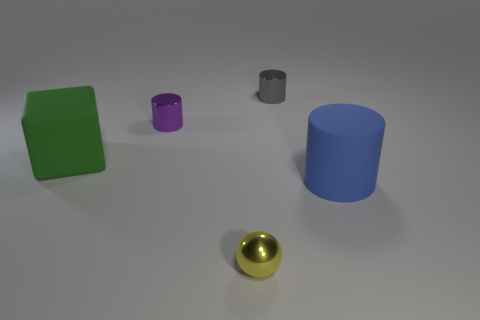Are there any yellow things made of the same material as the large green thing?
Your answer should be very brief. No. How many blue things are either cylinders or big things?
Your response must be concise. 1. Is the number of tiny purple things behind the large green object greater than the number of red matte blocks?
Give a very brief answer. Yes. Is the blue object the same size as the rubber cube?
Offer a terse response. Yes. There is a cylinder that is the same material as the purple thing; what is its color?
Give a very brief answer. Gray. Are there an equal number of large green rubber blocks that are on the left side of the block and blue objects behind the big blue matte object?
Ensure brevity in your answer.  Yes. What shape is the tiny thing to the right of the tiny yellow shiny ball to the left of the big blue object?
Keep it short and to the point. Cylinder. What material is the other tiny thing that is the same shape as the small purple thing?
Offer a terse response. Metal. There is a cylinder that is the same size as the purple metallic object; what is its color?
Give a very brief answer. Gray. Are there an equal number of blue cylinders behind the small gray metallic cylinder and big green matte balls?
Ensure brevity in your answer.  Yes. 